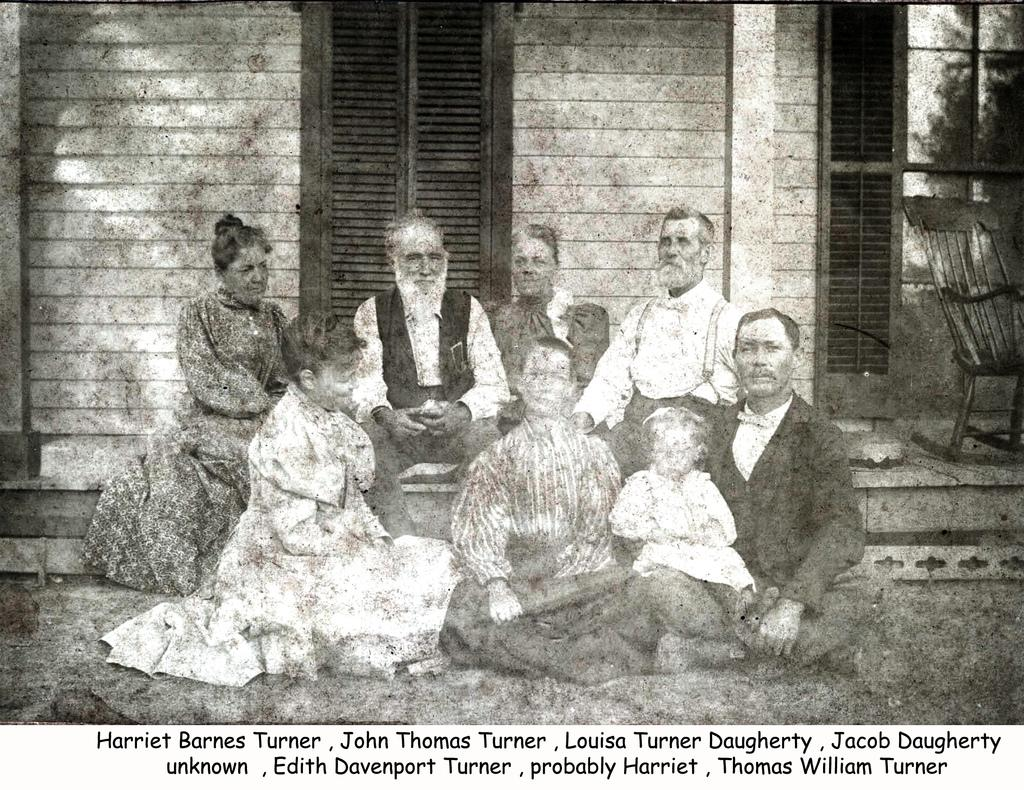What are the people in the image doing? The people in the image are sitting in the center. What can be seen in the background of the image? There is a wall and doors visible in the background. Where is the chair located in the image? The chair is on the right side of the image. What is written or displayed at the bottom of the image? There is text at the bottom of the image. How many desks are visible in the image? There are no desks present in the image. What type of question is being asked by the person sitting in the chair? There is no person sitting in the chair, and no question being asked in the image. 